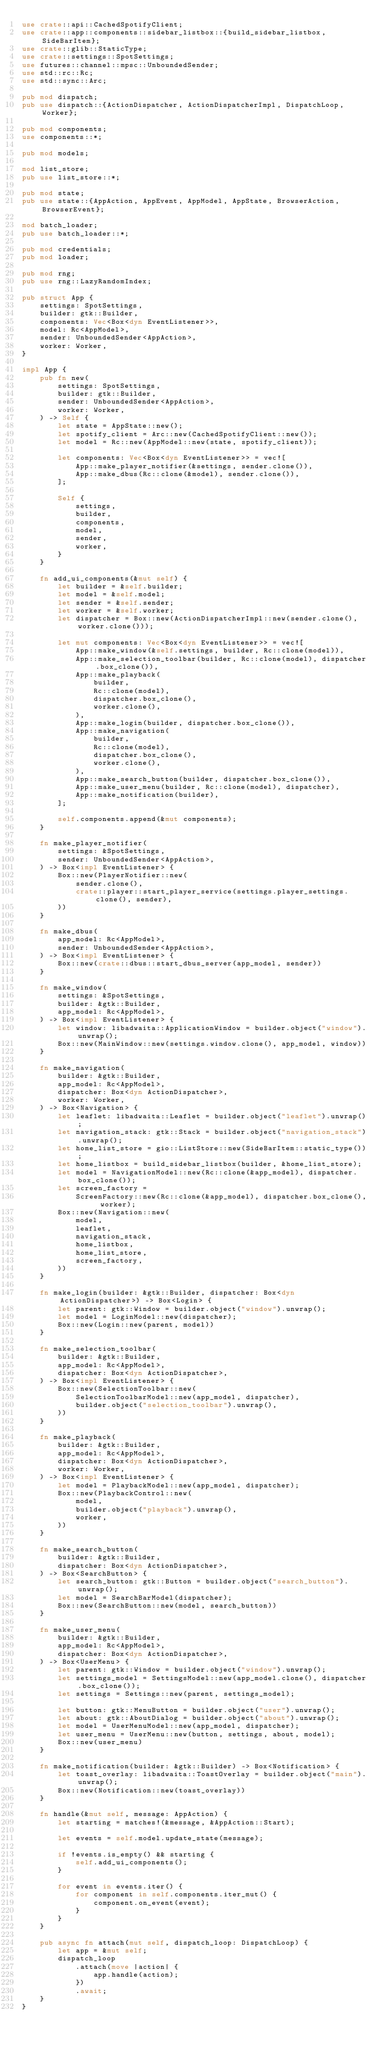Convert code to text. <code><loc_0><loc_0><loc_500><loc_500><_Rust_>use crate::api::CachedSpotifyClient;
use crate::app::components::sidebar_listbox::{build_sidebar_listbox, SideBarItem};
use crate::glib::StaticType;
use crate::settings::SpotSettings;
use futures::channel::mpsc::UnboundedSender;
use std::rc::Rc;
use std::sync::Arc;

pub mod dispatch;
pub use dispatch::{ActionDispatcher, ActionDispatcherImpl, DispatchLoop, Worker};

pub mod components;
use components::*;

pub mod models;

mod list_store;
pub use list_store::*;

pub mod state;
pub use state::{AppAction, AppEvent, AppModel, AppState, BrowserAction, BrowserEvent};

mod batch_loader;
pub use batch_loader::*;

pub mod credentials;
pub mod loader;

pub mod rng;
pub use rng::LazyRandomIndex;

pub struct App {
    settings: SpotSettings,
    builder: gtk::Builder,
    components: Vec<Box<dyn EventListener>>,
    model: Rc<AppModel>,
    sender: UnboundedSender<AppAction>,
    worker: Worker,
}

impl App {
    pub fn new(
        settings: SpotSettings,
        builder: gtk::Builder,
        sender: UnboundedSender<AppAction>,
        worker: Worker,
    ) -> Self {
        let state = AppState::new();
        let spotify_client = Arc::new(CachedSpotifyClient::new());
        let model = Rc::new(AppModel::new(state, spotify_client));

        let components: Vec<Box<dyn EventListener>> = vec![
            App::make_player_notifier(&settings, sender.clone()),
            App::make_dbus(Rc::clone(&model), sender.clone()),
        ];

        Self {
            settings,
            builder,
            components,
            model,
            sender,
            worker,
        }
    }

    fn add_ui_components(&mut self) {
        let builder = &self.builder;
        let model = &self.model;
        let sender = &self.sender;
        let worker = &self.worker;
        let dispatcher = Box::new(ActionDispatcherImpl::new(sender.clone(), worker.clone()));

        let mut components: Vec<Box<dyn EventListener>> = vec![
            App::make_window(&self.settings, builder, Rc::clone(model)),
            App::make_selection_toolbar(builder, Rc::clone(model), dispatcher.box_clone()),
            App::make_playback(
                builder,
                Rc::clone(model),
                dispatcher.box_clone(),
                worker.clone(),
            ),
            App::make_login(builder, dispatcher.box_clone()),
            App::make_navigation(
                builder,
                Rc::clone(model),
                dispatcher.box_clone(),
                worker.clone(),
            ),
            App::make_search_button(builder, dispatcher.box_clone()),
            App::make_user_menu(builder, Rc::clone(model), dispatcher),
            App::make_notification(builder),
        ];

        self.components.append(&mut components);
    }

    fn make_player_notifier(
        settings: &SpotSettings,
        sender: UnboundedSender<AppAction>,
    ) -> Box<impl EventListener> {
        Box::new(PlayerNotifier::new(
            sender.clone(),
            crate::player::start_player_service(settings.player_settings.clone(), sender),
        ))
    }

    fn make_dbus(
        app_model: Rc<AppModel>,
        sender: UnboundedSender<AppAction>,
    ) -> Box<impl EventListener> {
        Box::new(crate::dbus::start_dbus_server(app_model, sender))
    }

    fn make_window(
        settings: &SpotSettings,
        builder: &gtk::Builder,
        app_model: Rc<AppModel>,
    ) -> Box<impl EventListener> {
        let window: libadwaita::ApplicationWindow = builder.object("window").unwrap();
        Box::new(MainWindow::new(settings.window.clone(), app_model, window))
    }

    fn make_navigation(
        builder: &gtk::Builder,
        app_model: Rc<AppModel>,
        dispatcher: Box<dyn ActionDispatcher>,
        worker: Worker,
    ) -> Box<Navigation> {
        let leaflet: libadwaita::Leaflet = builder.object("leaflet").unwrap();
        let navigation_stack: gtk::Stack = builder.object("navigation_stack").unwrap();
        let home_list_store = gio::ListStore::new(SideBarItem::static_type());
        let home_listbox = build_sidebar_listbox(builder, &home_list_store);
        let model = NavigationModel::new(Rc::clone(&app_model), dispatcher.box_clone());
        let screen_factory =
            ScreenFactory::new(Rc::clone(&app_model), dispatcher.box_clone(), worker);
        Box::new(Navigation::new(
            model,
            leaflet,
            navigation_stack,
            home_listbox,
            home_list_store,
            screen_factory,
        ))
    }

    fn make_login(builder: &gtk::Builder, dispatcher: Box<dyn ActionDispatcher>) -> Box<Login> {
        let parent: gtk::Window = builder.object("window").unwrap();
        let model = LoginModel::new(dispatcher);
        Box::new(Login::new(parent, model))
    }

    fn make_selection_toolbar(
        builder: &gtk::Builder,
        app_model: Rc<AppModel>,
        dispatcher: Box<dyn ActionDispatcher>,
    ) -> Box<impl EventListener> {
        Box::new(SelectionToolbar::new(
            SelectionToolbarModel::new(app_model, dispatcher),
            builder.object("selection_toolbar").unwrap(),
        ))
    }

    fn make_playback(
        builder: &gtk::Builder,
        app_model: Rc<AppModel>,
        dispatcher: Box<dyn ActionDispatcher>,
        worker: Worker,
    ) -> Box<impl EventListener> {
        let model = PlaybackModel::new(app_model, dispatcher);
        Box::new(PlaybackControl::new(
            model,
            builder.object("playback").unwrap(),
            worker,
        ))
    }

    fn make_search_button(
        builder: &gtk::Builder,
        dispatcher: Box<dyn ActionDispatcher>,
    ) -> Box<SearchButton> {
        let search_button: gtk::Button = builder.object("search_button").unwrap();
        let model = SearchBarModel(dispatcher);
        Box::new(SearchButton::new(model, search_button))
    }

    fn make_user_menu(
        builder: &gtk::Builder,
        app_model: Rc<AppModel>,
        dispatcher: Box<dyn ActionDispatcher>,
    ) -> Box<UserMenu> {
        let parent: gtk::Window = builder.object("window").unwrap();
        let settings_model = SettingsModel::new(app_model.clone(), dispatcher.box_clone());
        let settings = Settings::new(parent, settings_model);

        let button: gtk::MenuButton = builder.object("user").unwrap();
        let about: gtk::AboutDialog = builder.object("about").unwrap();
        let model = UserMenuModel::new(app_model, dispatcher);
        let user_menu = UserMenu::new(button, settings, about, model);
        Box::new(user_menu)
    }

    fn make_notification(builder: &gtk::Builder) -> Box<Notification> {
        let toast_overlay: libadwaita::ToastOverlay = builder.object("main").unwrap();
        Box::new(Notification::new(toast_overlay))
    }

    fn handle(&mut self, message: AppAction) {
        let starting = matches!(&message, &AppAction::Start);

        let events = self.model.update_state(message);

        if !events.is_empty() && starting {
            self.add_ui_components();
        }

        for event in events.iter() {
            for component in self.components.iter_mut() {
                component.on_event(event);
            }
        }
    }

    pub async fn attach(mut self, dispatch_loop: DispatchLoop) {
        let app = &mut self;
        dispatch_loop
            .attach(move |action| {
                app.handle(action);
            })
            .await;
    }
}
</code> 